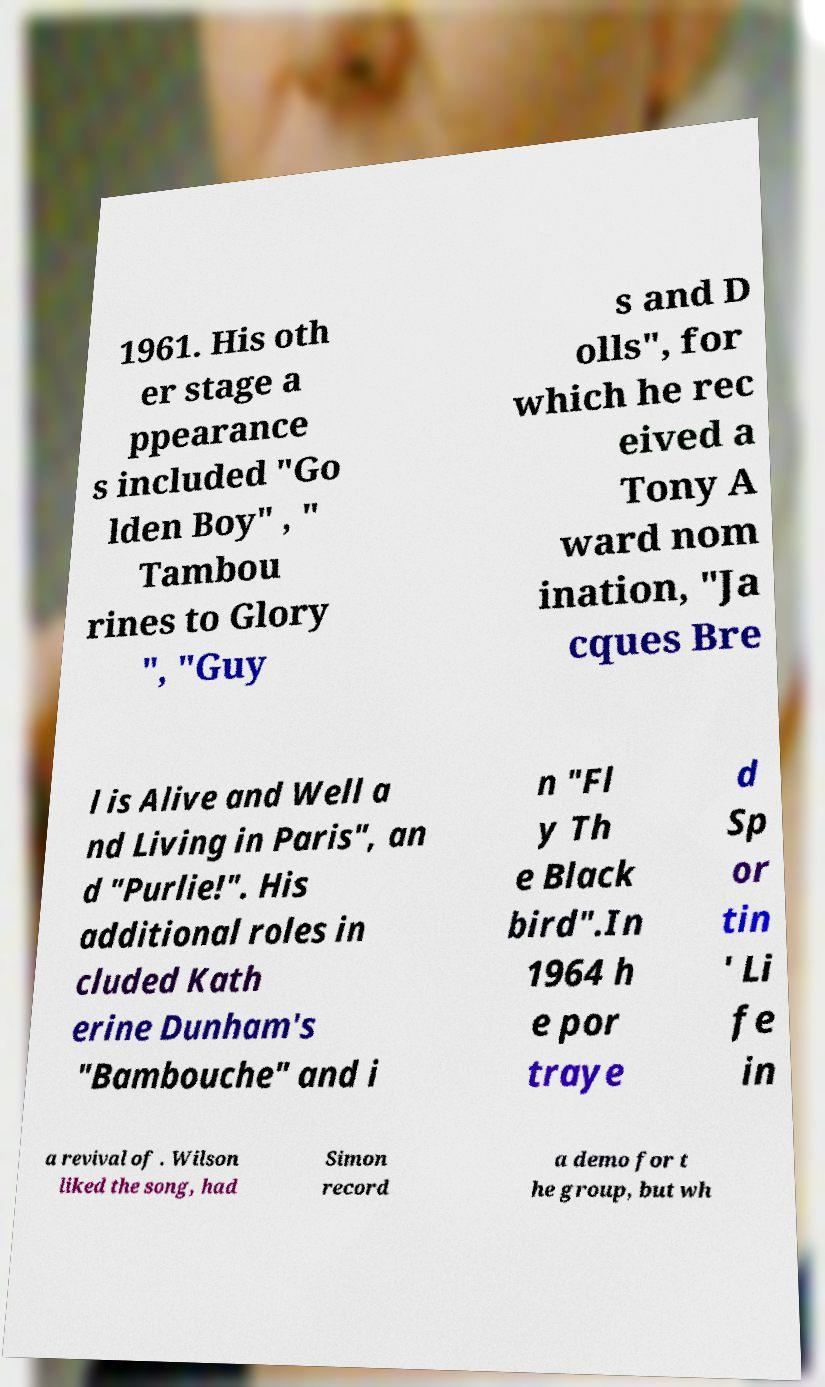There's text embedded in this image that I need extracted. Can you transcribe it verbatim? 1961. His oth er stage a ppearance s included "Go lden Boy" , " Tambou rines to Glory ", "Guy s and D olls", for which he rec eived a Tony A ward nom ination, "Ja cques Bre l is Alive and Well a nd Living in Paris", an d "Purlie!". His additional roles in cluded Kath erine Dunham's "Bambouche" and i n "Fl y Th e Black bird".In 1964 h e por traye d Sp or tin ' Li fe in a revival of . Wilson liked the song, had Simon record a demo for t he group, but wh 